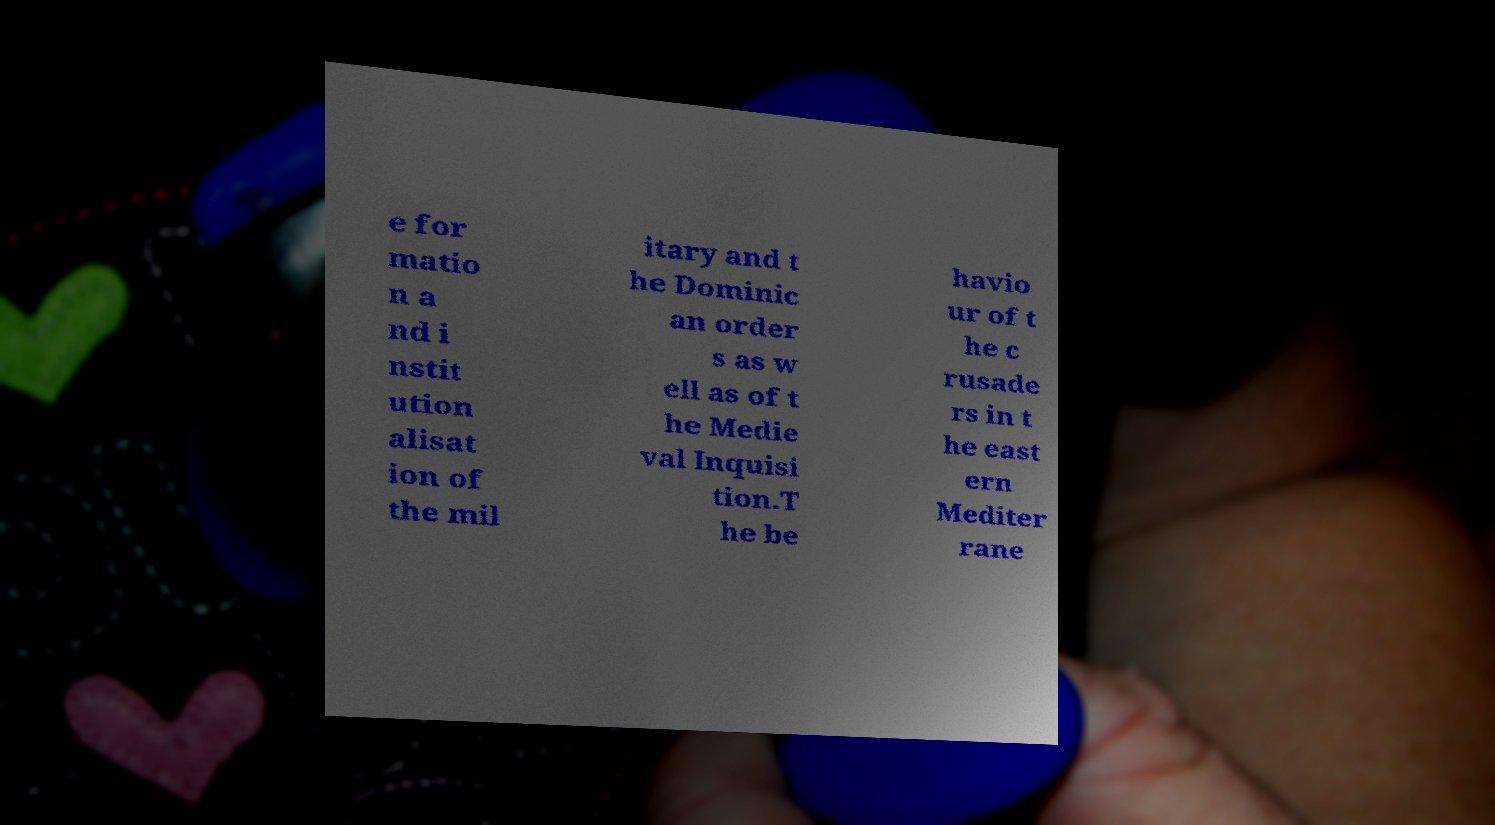What messages or text are displayed in this image? I need them in a readable, typed format. e for matio n a nd i nstit ution alisat ion of the mil itary and t he Dominic an order s as w ell as of t he Medie val Inquisi tion.T he be havio ur of t he c rusade rs in t he east ern Mediter rane 